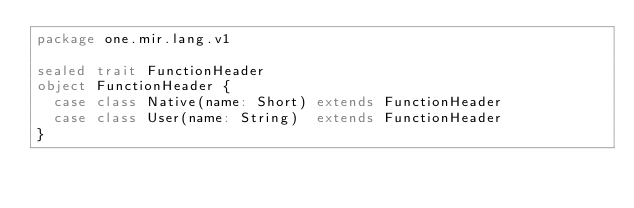<code> <loc_0><loc_0><loc_500><loc_500><_Scala_>package one.mir.lang.v1

sealed trait FunctionHeader
object FunctionHeader {
  case class Native(name: Short) extends FunctionHeader
  case class User(name: String)  extends FunctionHeader
}
</code> 